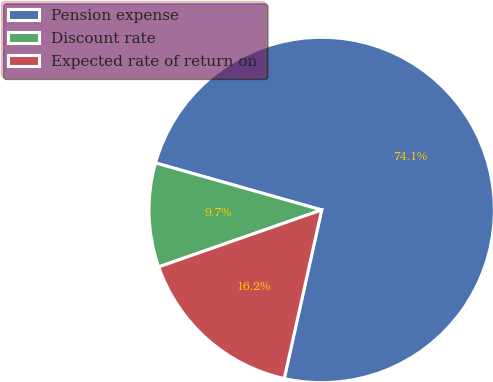Convert chart to OTSL. <chart><loc_0><loc_0><loc_500><loc_500><pie_chart><fcel>Pension expense<fcel>Discount rate<fcel>Expected rate of return on<nl><fcel>74.09%<fcel>9.74%<fcel>16.17%<nl></chart> 